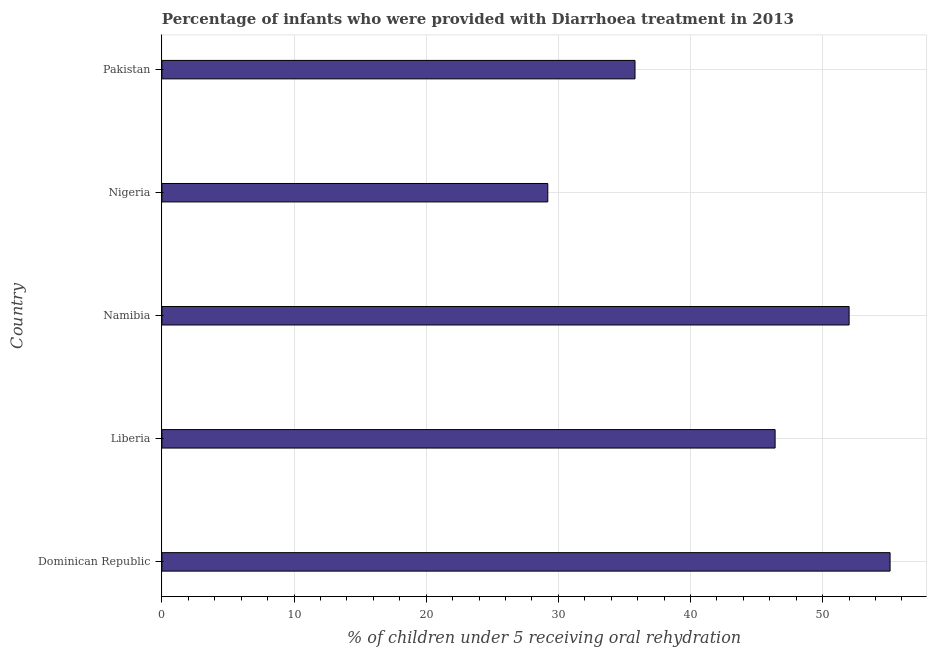What is the title of the graph?
Your response must be concise. Percentage of infants who were provided with Diarrhoea treatment in 2013. What is the label or title of the X-axis?
Make the answer very short. % of children under 5 receiving oral rehydration. What is the percentage of children who were provided with treatment diarrhoea in Liberia?
Your response must be concise. 46.4. Across all countries, what is the maximum percentage of children who were provided with treatment diarrhoea?
Provide a short and direct response. 55.1. Across all countries, what is the minimum percentage of children who were provided with treatment diarrhoea?
Keep it short and to the point. 29.2. In which country was the percentage of children who were provided with treatment diarrhoea maximum?
Keep it short and to the point. Dominican Republic. In which country was the percentage of children who were provided with treatment diarrhoea minimum?
Give a very brief answer. Nigeria. What is the sum of the percentage of children who were provided with treatment diarrhoea?
Your response must be concise. 218.5. What is the average percentage of children who were provided with treatment diarrhoea per country?
Offer a terse response. 43.7. What is the median percentage of children who were provided with treatment diarrhoea?
Your answer should be very brief. 46.4. What is the ratio of the percentage of children who were provided with treatment diarrhoea in Dominican Republic to that in Pakistan?
Offer a very short reply. 1.54. Is the difference between the percentage of children who were provided with treatment diarrhoea in Dominican Republic and Liberia greater than the difference between any two countries?
Provide a succinct answer. No. What is the difference between the highest and the second highest percentage of children who were provided with treatment diarrhoea?
Your answer should be very brief. 3.1. Is the sum of the percentage of children who were provided with treatment diarrhoea in Liberia and Namibia greater than the maximum percentage of children who were provided with treatment diarrhoea across all countries?
Provide a short and direct response. Yes. What is the difference between the highest and the lowest percentage of children who were provided with treatment diarrhoea?
Give a very brief answer. 25.9. How many bars are there?
Your response must be concise. 5. How many countries are there in the graph?
Keep it short and to the point. 5. What is the % of children under 5 receiving oral rehydration in Dominican Republic?
Your response must be concise. 55.1. What is the % of children under 5 receiving oral rehydration of Liberia?
Provide a short and direct response. 46.4. What is the % of children under 5 receiving oral rehydration in Namibia?
Offer a very short reply. 52. What is the % of children under 5 receiving oral rehydration of Nigeria?
Give a very brief answer. 29.2. What is the % of children under 5 receiving oral rehydration of Pakistan?
Your answer should be compact. 35.8. What is the difference between the % of children under 5 receiving oral rehydration in Dominican Republic and Liberia?
Provide a short and direct response. 8.7. What is the difference between the % of children under 5 receiving oral rehydration in Dominican Republic and Nigeria?
Ensure brevity in your answer.  25.9. What is the difference between the % of children under 5 receiving oral rehydration in Dominican Republic and Pakistan?
Your answer should be very brief. 19.3. What is the difference between the % of children under 5 receiving oral rehydration in Liberia and Namibia?
Your response must be concise. -5.6. What is the difference between the % of children under 5 receiving oral rehydration in Liberia and Nigeria?
Provide a succinct answer. 17.2. What is the difference between the % of children under 5 receiving oral rehydration in Namibia and Nigeria?
Your response must be concise. 22.8. What is the difference between the % of children under 5 receiving oral rehydration in Namibia and Pakistan?
Make the answer very short. 16.2. What is the ratio of the % of children under 5 receiving oral rehydration in Dominican Republic to that in Liberia?
Your answer should be very brief. 1.19. What is the ratio of the % of children under 5 receiving oral rehydration in Dominican Republic to that in Namibia?
Offer a very short reply. 1.06. What is the ratio of the % of children under 5 receiving oral rehydration in Dominican Republic to that in Nigeria?
Make the answer very short. 1.89. What is the ratio of the % of children under 5 receiving oral rehydration in Dominican Republic to that in Pakistan?
Offer a very short reply. 1.54. What is the ratio of the % of children under 5 receiving oral rehydration in Liberia to that in Namibia?
Your response must be concise. 0.89. What is the ratio of the % of children under 5 receiving oral rehydration in Liberia to that in Nigeria?
Your answer should be compact. 1.59. What is the ratio of the % of children under 5 receiving oral rehydration in Liberia to that in Pakistan?
Offer a terse response. 1.3. What is the ratio of the % of children under 5 receiving oral rehydration in Namibia to that in Nigeria?
Offer a terse response. 1.78. What is the ratio of the % of children under 5 receiving oral rehydration in Namibia to that in Pakistan?
Keep it short and to the point. 1.45. What is the ratio of the % of children under 5 receiving oral rehydration in Nigeria to that in Pakistan?
Keep it short and to the point. 0.82. 